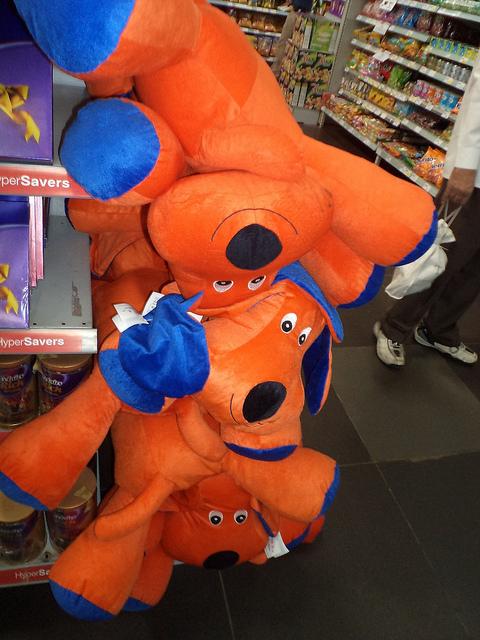What color are the stuffed dogs?
Be succinct. Orange. Is this a grocery store?
Keep it brief. Yes. Are the dogs happy?
Answer briefly. Yes. 